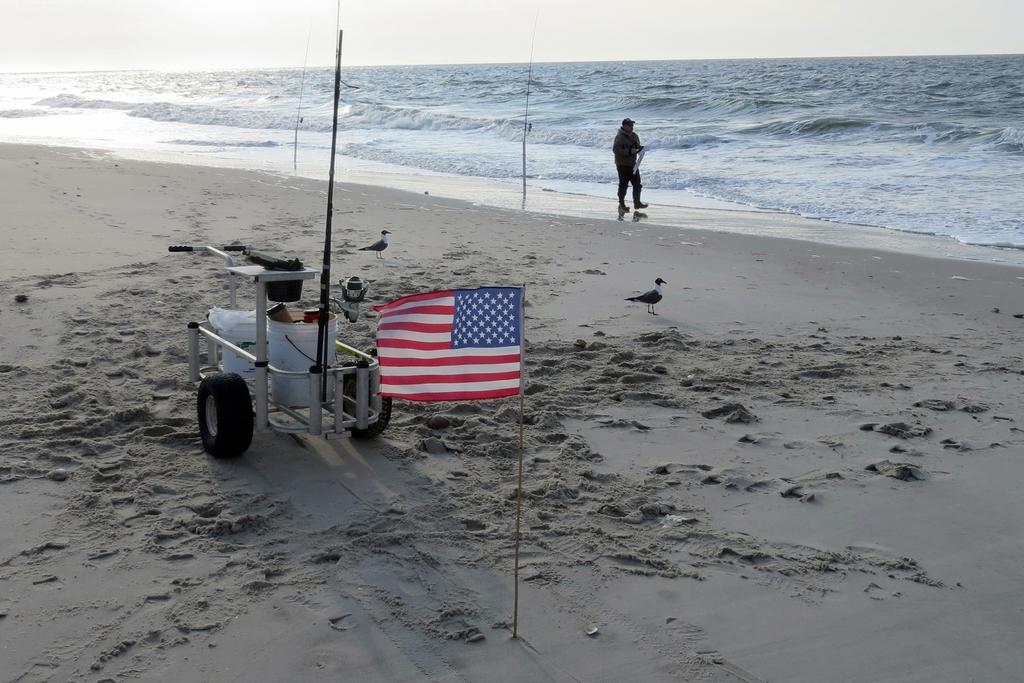What can be found on the sand in the image? There is a machine and birds on the sand in the image. What is the flag attached to? The flag is attached to a pole. What type of environment is depicted in the image? The image shows a sandy environment with water and the sky visible in the background. Can you describe the person in the image? There is a person in the image, but no specific details about their appearance or actions are provided. What decision does the hole in the sand make in the image? There is no hole present in the image, so it cannot make any decisions. 